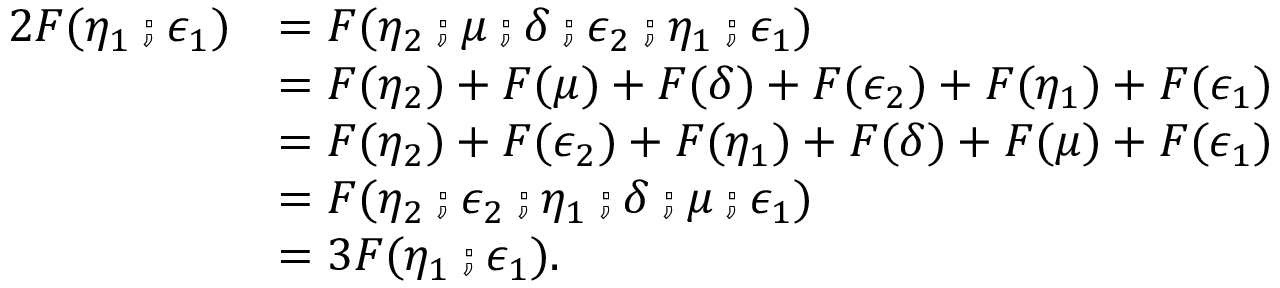<formula> <loc_0><loc_0><loc_500><loc_500>\begin{array} { r l } { 2 F ( \eta _ { 1 } \ f c m p \epsilon _ { 1 } ) } & { = F ( \eta _ { 2 } \ f c m p \mu \ f c m p \delta \ f c m p \epsilon _ { 2 } \ f c m p \eta _ { 1 } \ f c m p \epsilon _ { 1 } ) } \\ & { = F ( \eta _ { 2 } ) + F ( \mu ) + F ( \delta ) + F ( \epsilon _ { 2 } ) + F ( \eta _ { 1 } ) + F ( \epsilon _ { 1 } ) } \\ & { = F ( \eta _ { 2 } ) + F ( \epsilon _ { 2 } ) + F ( \eta _ { 1 } ) + F ( \delta ) + F ( \mu ) + F ( \epsilon _ { 1 } ) } \\ & { = F ( \eta _ { 2 } \ f c m p \epsilon _ { 2 } \ f c m p \eta _ { 1 } \ f c m p \delta \ f c m p \mu \ f c m p \epsilon _ { 1 } ) } \\ & { = 3 F ( \eta _ { 1 } \ f c m p \epsilon _ { 1 } ) . } \end{array}</formula> 